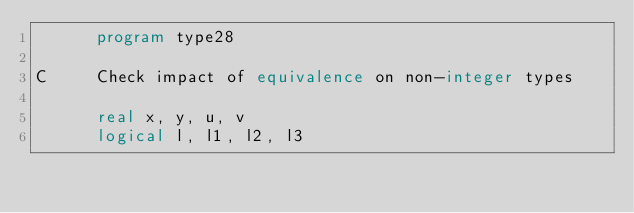Convert code to text. <code><loc_0><loc_0><loc_500><loc_500><_FORTRAN_>      program type28

C     Check impact of equivalence on non-integer types

      real x, y, u, v
      logical l, l1, l2, l3</code> 